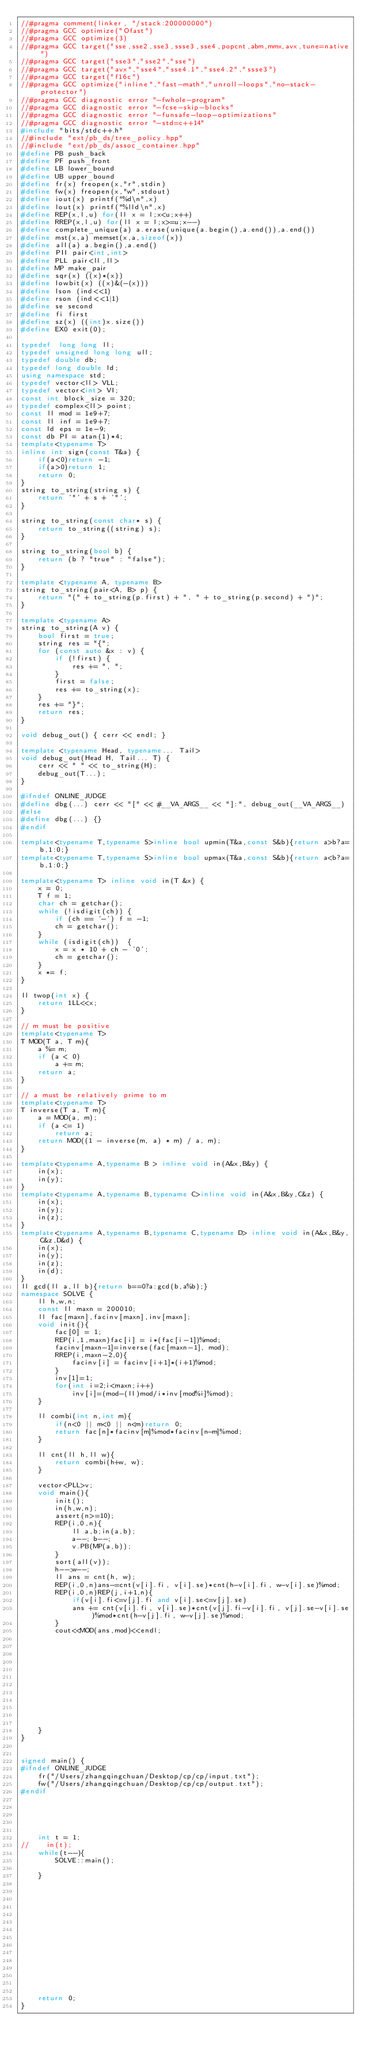Convert code to text. <code><loc_0><loc_0><loc_500><loc_500><_C++_>//#pragma comment(linker, "/stack:200000000")
//#pragma GCC optimize("Ofast")
//#pragma GCC optimize(3)
//#pragma GCC target("sse,sse2,sse3,ssse3,sse4,popcnt,abm,mmx,avx,tune=native")
//#pragma GCC target("sse3","sse2","sse")
//#pragma GCC target("avx","sse4","sse4.1","sse4.2","ssse3")
//#pragma GCC target("f16c")
//#pragma GCC optimize("inline","fast-math","unroll-loops","no-stack-protector")
//#pragma GCC diagnostic error "-fwhole-program"
//#pragma GCC diagnostic error "-fcse-skip-blocks"
//#pragma GCC diagnostic error "-funsafe-loop-optimizations"
//#pragma GCC diagnostic error "-std=c++14"
#include "bits/stdc++.h"
//#include "ext/pb_ds/tree_policy.hpp"
//#include "ext/pb_ds/assoc_container.hpp"
#define PB push_back
#define PF push_front
#define LB lower_bound
#define UB upper_bound
#define fr(x) freopen(x,"r",stdin)
#define fw(x) freopen(x,"w",stdout)
#define iout(x) printf("%d\n",x)
#define lout(x) printf("%lld\n",x)
#define REP(x,l,u) for(ll x = l;x<u;x++)
#define RREP(x,l,u) for(ll x = l;x>=u;x--)
#define complete_unique(a) a.erase(unique(a.begin(),a.end()),a.end())
#define mst(x,a) memset(x,a,sizeof(x))
#define all(a) a.begin(),a.end()
#define PII pair<int,int>
#define PLL pair<ll,ll>
#define MP make_pair
#define sqr(x) ((x)*(x))
#define lowbit(x) ((x)&(-(x)))
#define lson (ind<<1)
#define rson (ind<<1|1)
#define se second
#define fi first
#define sz(x) ((int)x.size())
#define EX0 exit(0);

typedef  long long ll;
typedef unsigned long long ull;
typedef double db;
typedef long double ld;
using namespace std;
typedef vector<ll> VLL;
typedef vector<int> VI;
const int block_size = 320;
typedef complex<ll> point;
const ll mod = 1e9+7;
const ll inf = 1e9+7;
const ld eps = 1e-9;
const db PI = atan(1)*4;
template<typename T>
inline int sign(const T&a) {
    if(a<0)return -1;
    if(a>0)return 1;
    return 0;
}
string to_string(string s) {
    return '"' + s + '"';
}

string to_string(const char* s) {
    return to_string((string) s);
}

string to_string(bool b) {
    return (b ? "true" : "false");
}

template <typename A, typename B>
string to_string(pair<A, B> p) {
    return "(" + to_string(p.first) + ", " + to_string(p.second) + ")";
}

template <typename A>
string to_string(A v) {
    bool first = true;
    string res = "{";
    for (const auto &x : v) {
        if (!first) {
            res += ", ";
        }
        first = false;
        res += to_string(x);
    }
    res += "}";
    return res;
}

void debug_out() { cerr << endl; }

template <typename Head, typename... Tail>
void debug_out(Head H, Tail... T) {
    cerr << " " << to_string(H);
    debug_out(T...);
}

#ifndef ONLINE_JUDGE
#define dbg(...) cerr << "[" << #__VA_ARGS__ << "]:", debug_out(__VA_ARGS__)
#else
#define dbg(...) {}
#endif

template<typename T,typename S>inline bool upmin(T&a,const S&b){return a>b?a=b,1:0;}
template<typename T,typename S>inline bool upmax(T&a,const S&b){return a<b?a=b,1:0;}

template<typename T> inline void in(T &x) {
    x = 0;
    T f = 1;
    char ch = getchar();
    while (!isdigit(ch)) {
        if (ch == '-') f = -1;
        ch = getchar();
    }
    while (isdigit(ch))  {
        x = x * 10 + ch - '0';
        ch = getchar();
    }
    x *= f;
}

ll twop(int x) {
    return 1LL<<x;
}

// m must be positive
template<typename T>
T MOD(T a, T m){
    a %= m;
    if (a < 0)
        a += m;
    return a;
}

// a must be relatively prime to m
template<typename T>
T inverse(T a, T m){
    a = MOD(a, m);
    if (a <= 1)
        return a;
    return MOD((1 - inverse(m, a) * m) / a, m);
}

template<typename A,typename B > inline void in(A&x,B&y) {
    in(x);
    in(y);
}
template<typename A,typename B,typename C>inline void in(A&x,B&y,C&z) {
    in(x);
    in(y);
    in(z);
}
template<typename A,typename B,typename C,typename D> inline void in(A&x,B&y,C&z,D&d) {
    in(x);
    in(y);
    in(z);
    in(d);
}
ll gcd(ll a,ll b){return b==0?a:gcd(b,a%b);}
namespace SOLVE {
    ll h,w,n;
    const ll maxn = 200010;
    ll fac[maxn],facinv[maxn],inv[maxn];
    void init(){
        fac[0] = 1;
        REP(i,1,maxn)fac[i] = i*(fac[i-1])%mod;
        facinv[maxn-1]=inverse(fac[maxn-1], mod);
        RREP(i,maxn-2,0){
            facinv[i] = facinv[i+1]*(i+1)%mod;
        }
        inv[1]=1;
        for(int i=2;i<maxn;i++)
            inv[i]=(mod-(ll)mod/i*inv[mod%i]%mod);
    }
    
    ll combi(int n,int m){
        if(n<0 || m<0 || n<m)return 0;
        return fac[n]*facinv[m]%mod*facinv[n-m]%mod;
    }
    
    ll cnt(ll h,ll w){
        return combi(h+w, w);
    }

    vector<PLL>v;
    void main(){
        init();
        in(h,w,n);
        assert(n>=10);
        REP(i,0,n){
            ll a,b;in(a,b);
            a--; b--;
            v.PB(MP(a,b));
        }
        sort(all(v));
        h--;w--;
        ll ans = cnt(h, w);
        REP(i,0,n)ans-=cnt(v[i].fi, v[i].se)*cnt(h-v[i].fi, w-v[i].se)%mod;
        REP(i,0,n)REP(j,i+1,n){
            if(v[i].fi<=v[j].fi and v[i].se<=v[j].se)
            ans += cnt(v[i].fi, v[i].se)*cnt(v[j].fi-v[i].fi, v[j].se-v[i].se)%mod*cnt(h-v[j].fi, w-v[j].se)%mod;
        }
        cout<<MOD(ans,mod)<<endl;
        
        
        
        
        
        
        
        
        
        
        
        
    }
}


signed main() {
#ifndef ONLINE_JUDGE
    fr("/Users/zhangqingchuan/Desktop/cp/cp/input.txt");
    fw("/Users/zhangqingchuan/Desktop/cp/cp/output.txt");
#endif
    
    
    
    
    
    int t = 1;
//    in(t);
    while(t--){
        SOLVE::main();

    }
    
    
    
    
    
    
    
    
    
    
    
    
    
    
    
    return 0;
}
</code> 